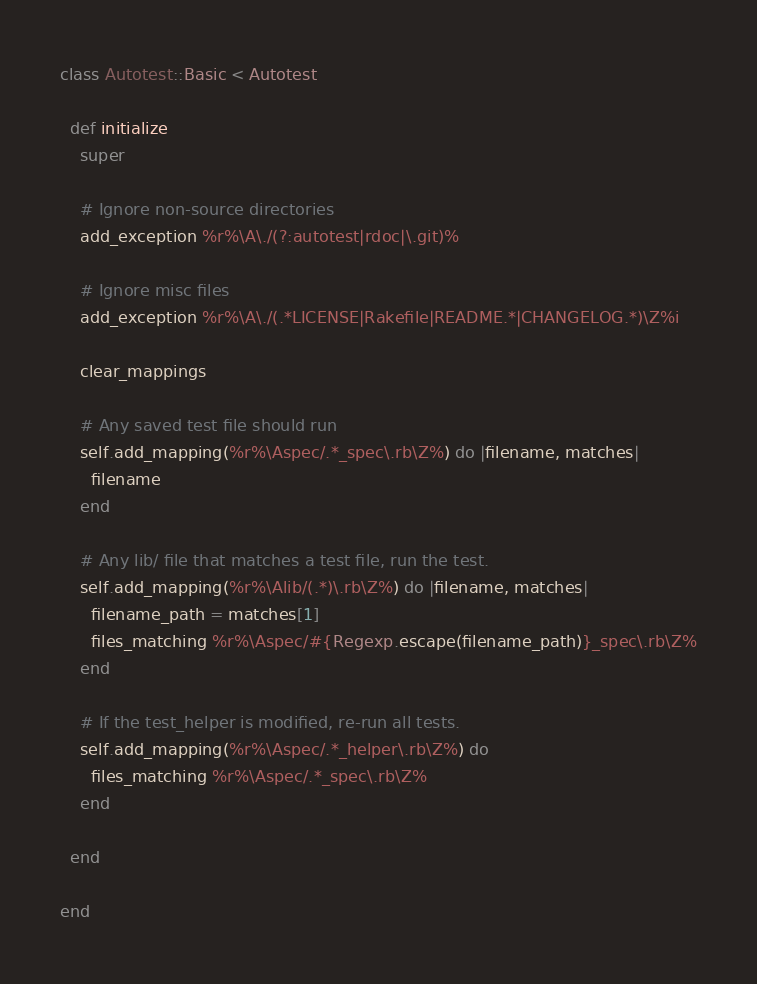<code> <loc_0><loc_0><loc_500><loc_500><_Ruby_>class Autotest::Basic < Autotest
  
  def initialize
    super
    
    # Ignore non-source directories
    add_exception %r%\A\./(?:autotest|rdoc|\.git)%
    
    # Ignore misc files
    add_exception %r%\A\./(.*LICENSE|Rakefile|README.*|CHANGELOG.*)\Z%i
    
    clear_mappings
    
    # Any saved test file should run
    self.add_mapping(%r%\Aspec/.*_spec\.rb\Z%) do |filename, matches|
      filename
    end
    
    # Any lib/ file that matches a test file, run the test.
    self.add_mapping(%r%\Alib/(.*)\.rb\Z%) do |filename, matches|
      filename_path = matches[1]
      files_matching %r%\Aspec/#{Regexp.escape(filename_path)}_spec\.rb\Z%
    end
    
    # If the test_helper is modified, re-run all tests.
    self.add_mapping(%r%\Aspec/.*_helper\.rb\Z%) do
      files_matching %r%\Aspec/.*_spec\.rb\Z%
    end
    
  end
  
end</code> 